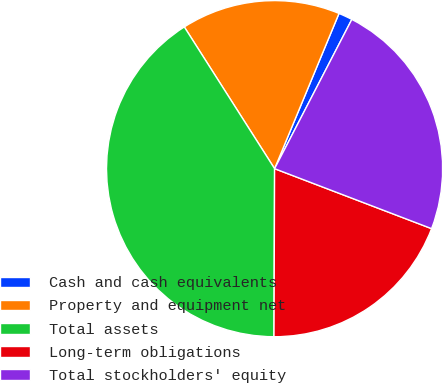Convert chart. <chart><loc_0><loc_0><loc_500><loc_500><pie_chart><fcel>Cash and cash equivalents<fcel>Property and equipment net<fcel>Total assets<fcel>Long-term obligations<fcel>Total stockholders' equity<nl><fcel>1.34%<fcel>15.29%<fcel>40.92%<fcel>19.25%<fcel>23.21%<nl></chart> 